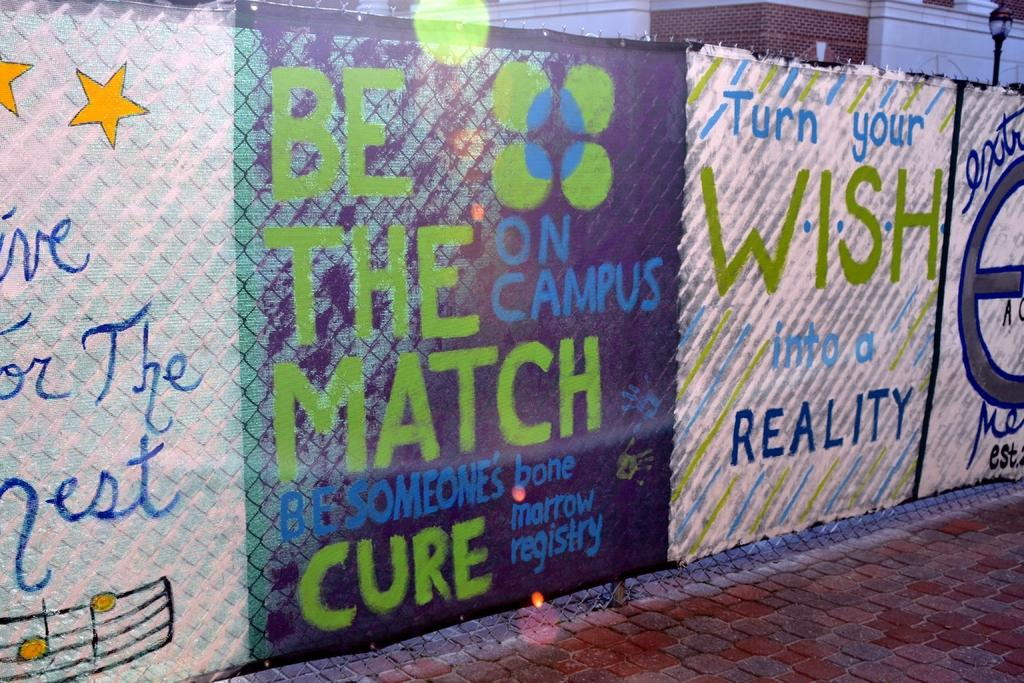<image>
Create a compact narrative representing the image presented. banner over a fence with one that says 'turn your wish into a reality' 